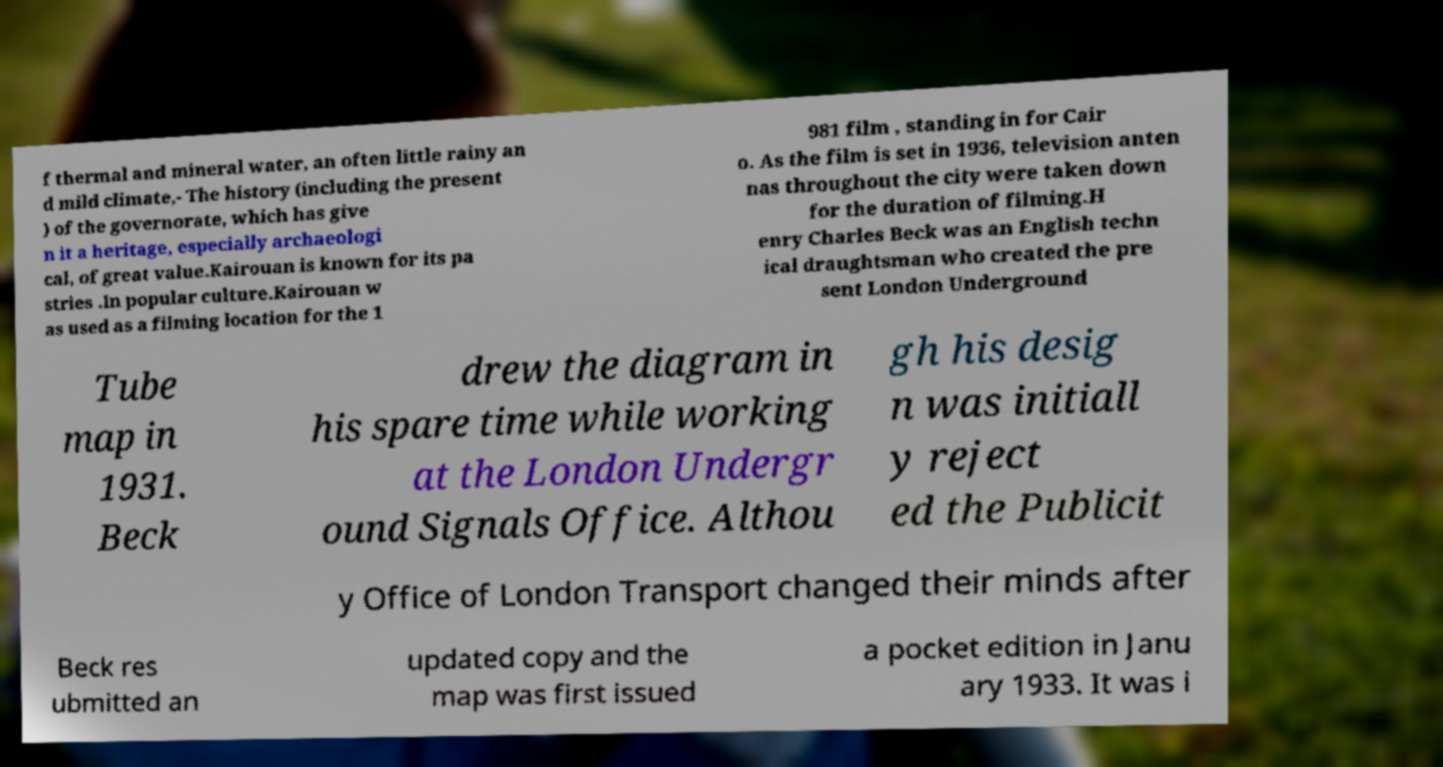For documentation purposes, I need the text within this image transcribed. Could you provide that? f thermal and mineral water, an often little rainy an d mild climate,- The history (including the present ) of the governorate, which has give n it a heritage, especially archaeologi cal, of great value.Kairouan is known for its pa stries .In popular culture.Kairouan w as used as a filming location for the 1 981 film , standing in for Cair o. As the film is set in 1936, television anten nas throughout the city were taken down for the duration of filming.H enry Charles Beck was an English techn ical draughtsman who created the pre sent London Underground Tube map in 1931. Beck drew the diagram in his spare time while working at the London Undergr ound Signals Office. Althou gh his desig n was initiall y reject ed the Publicit y Office of London Transport changed their minds after Beck res ubmitted an updated copy and the map was first issued a pocket edition in Janu ary 1933. It was i 